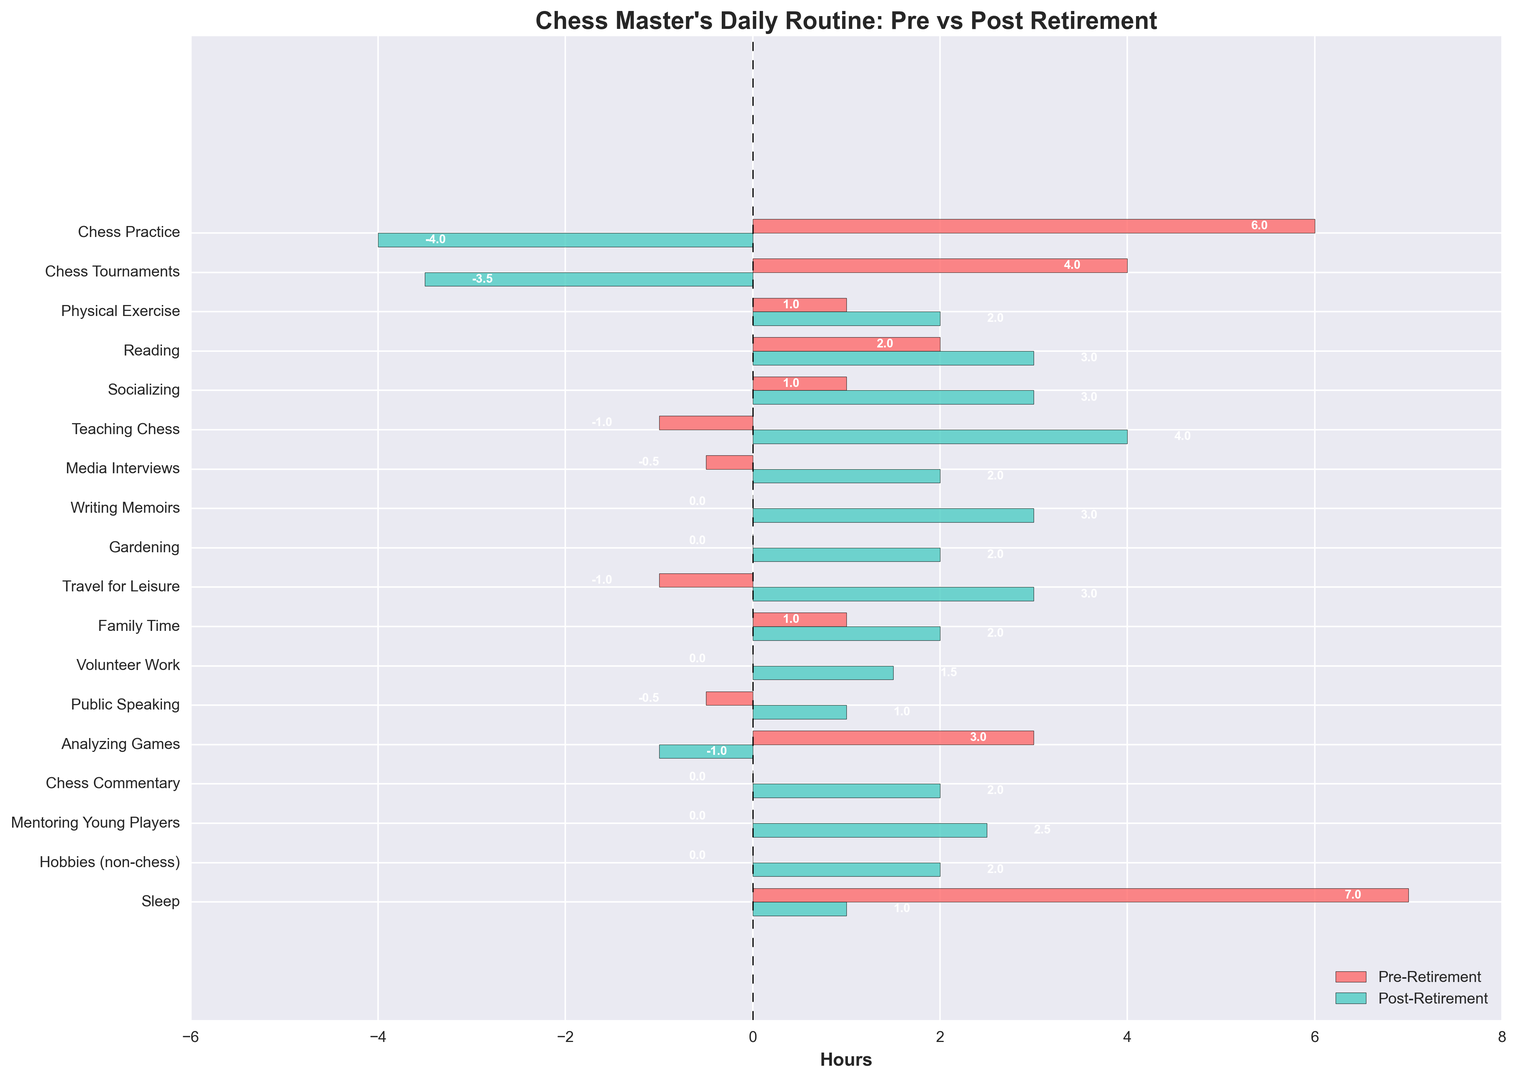What's the total time allocated to Chess Practice and Chess Tournaments post-retirement? To find the total time allocation, we need to sum the hours for Chess Practice and Chess Tournaments post-retirement. Chess Practice is -4 hours and Chess Tournaments is -3.5 hours. Adding these together: -4 + (-3.5) = -7.5 hours
Answer: -7.5 hours Which activity has seen the largest increase in time allocation post-retirement? To determine this, we compare pre-retirement and post-retirement hours for each activity. The activity with the largest positive shift (post-retirement minus pre-retirement) should be identified. Teaching Chess shifts from -1 to 4 hours, which is a 5-hour increase.
Answer: Teaching Chess Which two activities have the same post-retirement hours? We need to look for activities with identical post-retirement hours. Writing Memoirs, Chess Commentary, and Gardening all have 2 hours post-retirement, making them a valid set.
Answer: Writing Memoirs, Chess Commentary, Gardening By how many hours did physical exercise increase after retirement? The bar representing Physical Exercise shows 1 hour pre-retirement and 2 hours post-retirement. The increase is 2 - 1 = 1 hour.
Answer: 1 hour Which activity has the highest allocated time pre-retirement, and how many hours is it? By examining the pre-retirement bars, we find that Sleep has the highest allocation with 7 hours.
Answer: Sleep, 7 hours What is the total time dedicated to Socializing and Reading post-retirement? Adding the post-retirement hours for Socializing (3) and Reading (3): 3 + 3 = 6 hours.
Answer: 6 hours Which activity displays a negative value post-retirement and what does it indicate? Chess Practice has a -4 hours post-retirement, indicating the retired chess master has drastically reduced or entirely stopped practicing chess.
Answer: Chess Practice, -4 hours How much more time is spent on Socializing compared to Physical Exercise post-retirement? Socializing has 3 hours, and Physical Exercise has 2 hours post-retirement. The difference is 3 - 2 = 1 hour.
Answer: 1 hour Which activity saw no change in time allocation pre and post-retirement? By comparing, we see no activity with unchanged values. However, certain non-chess hobbies had zero pre-retirement hours and now have new hours post-retirement.
Answer: None 